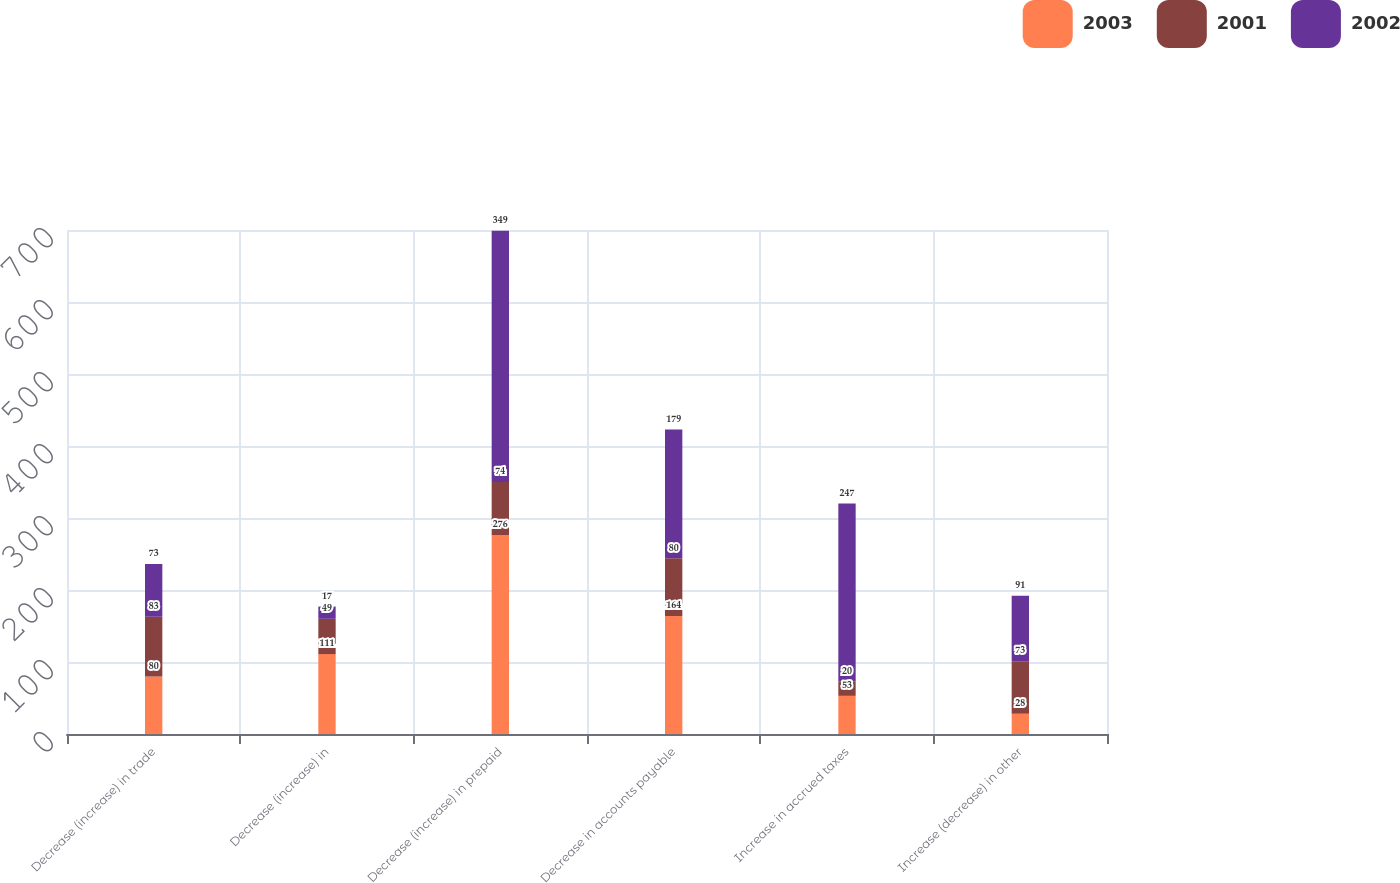Convert chart to OTSL. <chart><loc_0><loc_0><loc_500><loc_500><stacked_bar_chart><ecel><fcel>Decrease (increase) in trade<fcel>Decrease (increase) in<fcel>Decrease (increase) in prepaid<fcel>Decrease in accounts payable<fcel>Increase in accrued taxes<fcel>Increase (decrease) in other<nl><fcel>2003<fcel>80<fcel>111<fcel>276<fcel>164<fcel>53<fcel>28<nl><fcel>2001<fcel>83<fcel>49<fcel>74<fcel>80<fcel>20<fcel>73<nl><fcel>2002<fcel>73<fcel>17<fcel>349<fcel>179<fcel>247<fcel>91<nl></chart> 